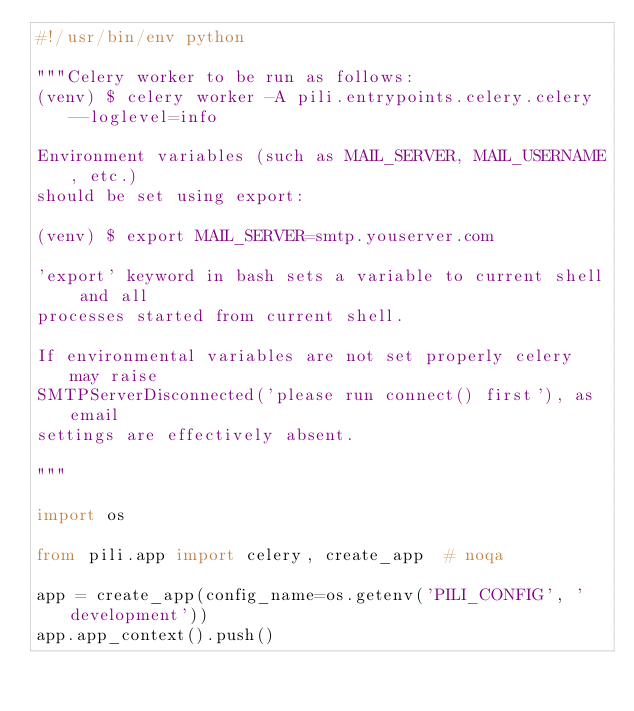<code> <loc_0><loc_0><loc_500><loc_500><_Python_>#!/usr/bin/env python

"""Celery worker to be run as follows:
(venv) $ celery worker -A pili.entrypoints.celery.celery --loglevel=info

Environment variables (such as MAIL_SERVER, MAIL_USERNAME, etc.)
should be set using export:

(venv) $ export MAIL_SERVER=smtp.youserver.com

'export' keyword in bash sets a variable to current shell and all
processes started from current shell.

If environmental variables are not set properly celery may raise
SMTPServerDisconnected('please run connect() first'), as email
settings are effectively absent.

"""

import os

from pili.app import celery, create_app  # noqa

app = create_app(config_name=os.getenv('PILI_CONFIG', 'development'))
app.app_context().push()
</code> 